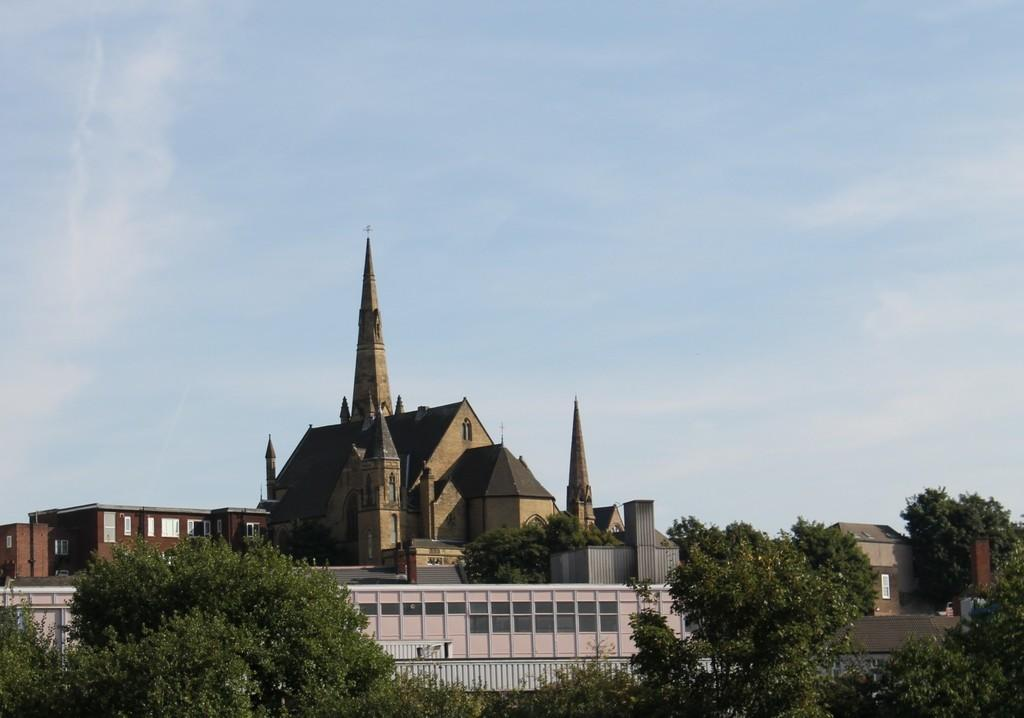What type of vegetation is in the foreground of the image? There are trees in the foreground of the image. What type of structures can be seen in the middle of the image? There are buildings in the middle of the image. What is visible at the top of the image? The sky is visible at the top of the image. What type of quill is being used to write on the buildings in the image? There is no quill present in the image, and the buildings are not being written on. How many people are getting a haircut in the image? There is no haircut being performed in the image. What type of nut can be seen growing on the trees in the image? There is no nut visible on the trees in the image; only the trees themselves are present. 